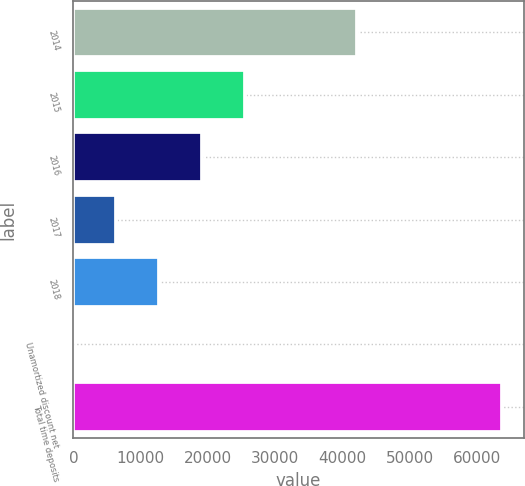Convert chart. <chart><loc_0><loc_0><loc_500><loc_500><bar_chart><fcel>2014<fcel>2015<fcel>2016<fcel>2017<fcel>2018<fcel>Unamortized discount net<fcel>Total time deposits<nl><fcel>42223<fcel>25501<fcel>19126.5<fcel>6377.5<fcel>12752<fcel>3<fcel>63748<nl></chart> 